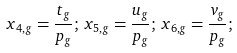Convert formula to latex. <formula><loc_0><loc_0><loc_500><loc_500>x _ { 4 , g } = \frac { t _ { g } } { p _ { g } } ; \, x _ { 5 , g } = \frac { u _ { g } } { p _ { g } } ; \, x _ { 6 , g } = \frac { v _ { g } } { p _ { g } } ; \,</formula> 